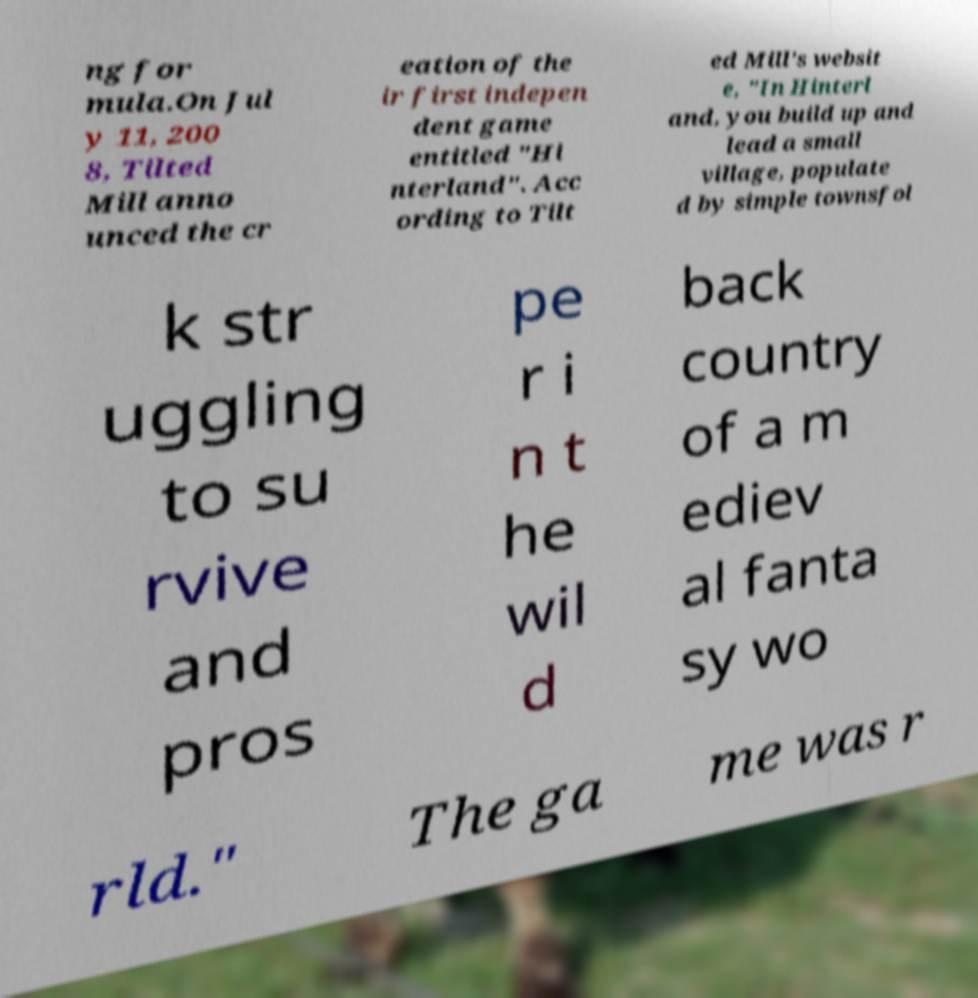Can you read and provide the text displayed in the image?This photo seems to have some interesting text. Can you extract and type it out for me? ng for mula.On Jul y 11, 200 8, Tilted Mill anno unced the cr eation of the ir first indepen dent game entitled "Hi nterland". Acc ording to Tilt ed Mill's websit e, "In Hinterl and, you build up and lead a small village, populate d by simple townsfol k str uggling to su rvive and pros pe r i n t he wil d back country of a m ediev al fanta sy wo rld." The ga me was r 